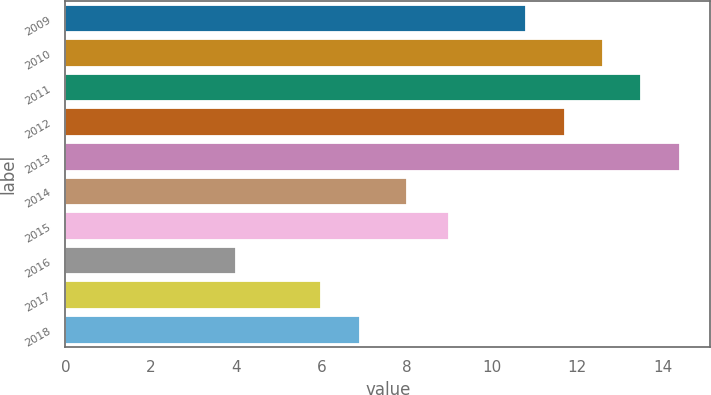<chart> <loc_0><loc_0><loc_500><loc_500><bar_chart><fcel>2009<fcel>2010<fcel>2011<fcel>2012<fcel>2013<fcel>2014<fcel>2015<fcel>2016<fcel>2017<fcel>2018<nl><fcel>10.8<fcel>12.6<fcel>13.5<fcel>11.7<fcel>14.4<fcel>8<fcel>9<fcel>4<fcel>6<fcel>6.9<nl></chart> 